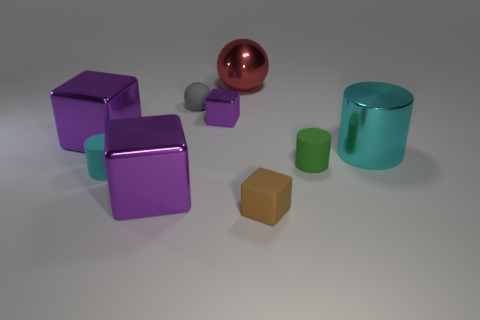How many other cyan rubber objects have the same shape as the cyan rubber thing?
Offer a very short reply. 0. What material is the other tiny cylinder that is the same color as the shiny cylinder?
Give a very brief answer. Rubber. How many rubber cylinders are there?
Provide a short and direct response. 2. Are there any big purple cylinders that have the same material as the red sphere?
Give a very brief answer. No. What size is the matte thing that is the same color as the big shiny cylinder?
Your answer should be very brief. Small. Do the metal thing that is behind the tiny gray sphere and the matte thing that is to the right of the tiny brown rubber block have the same size?
Provide a succinct answer. No. What is the size of the metal thing that is behind the gray thing?
Give a very brief answer. Large. Is there a large shiny cube of the same color as the tiny shiny thing?
Offer a terse response. Yes. There is a sphere that is right of the small purple thing; is there a metallic object on the right side of it?
Offer a very short reply. Yes. Does the rubber cube have the same size as the metal object right of the brown rubber thing?
Offer a very short reply. No. 